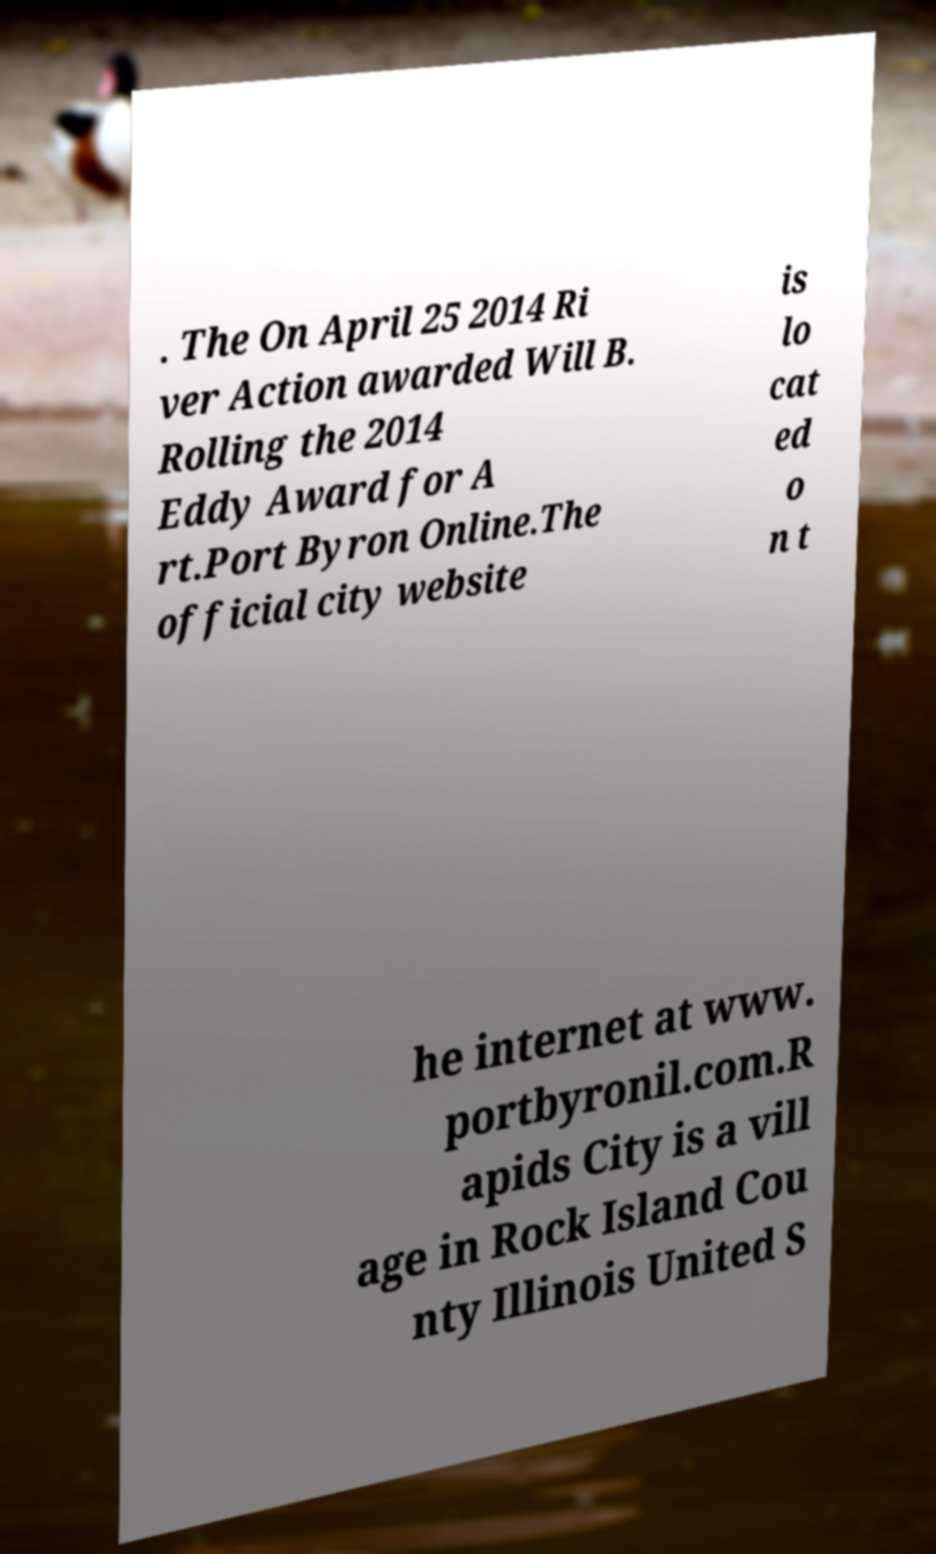There's text embedded in this image that I need extracted. Can you transcribe it verbatim? . The On April 25 2014 Ri ver Action awarded Will B. Rolling the 2014 Eddy Award for A rt.Port Byron Online.The official city website is lo cat ed o n t he internet at www. portbyronil.com.R apids City is a vill age in Rock Island Cou nty Illinois United S 